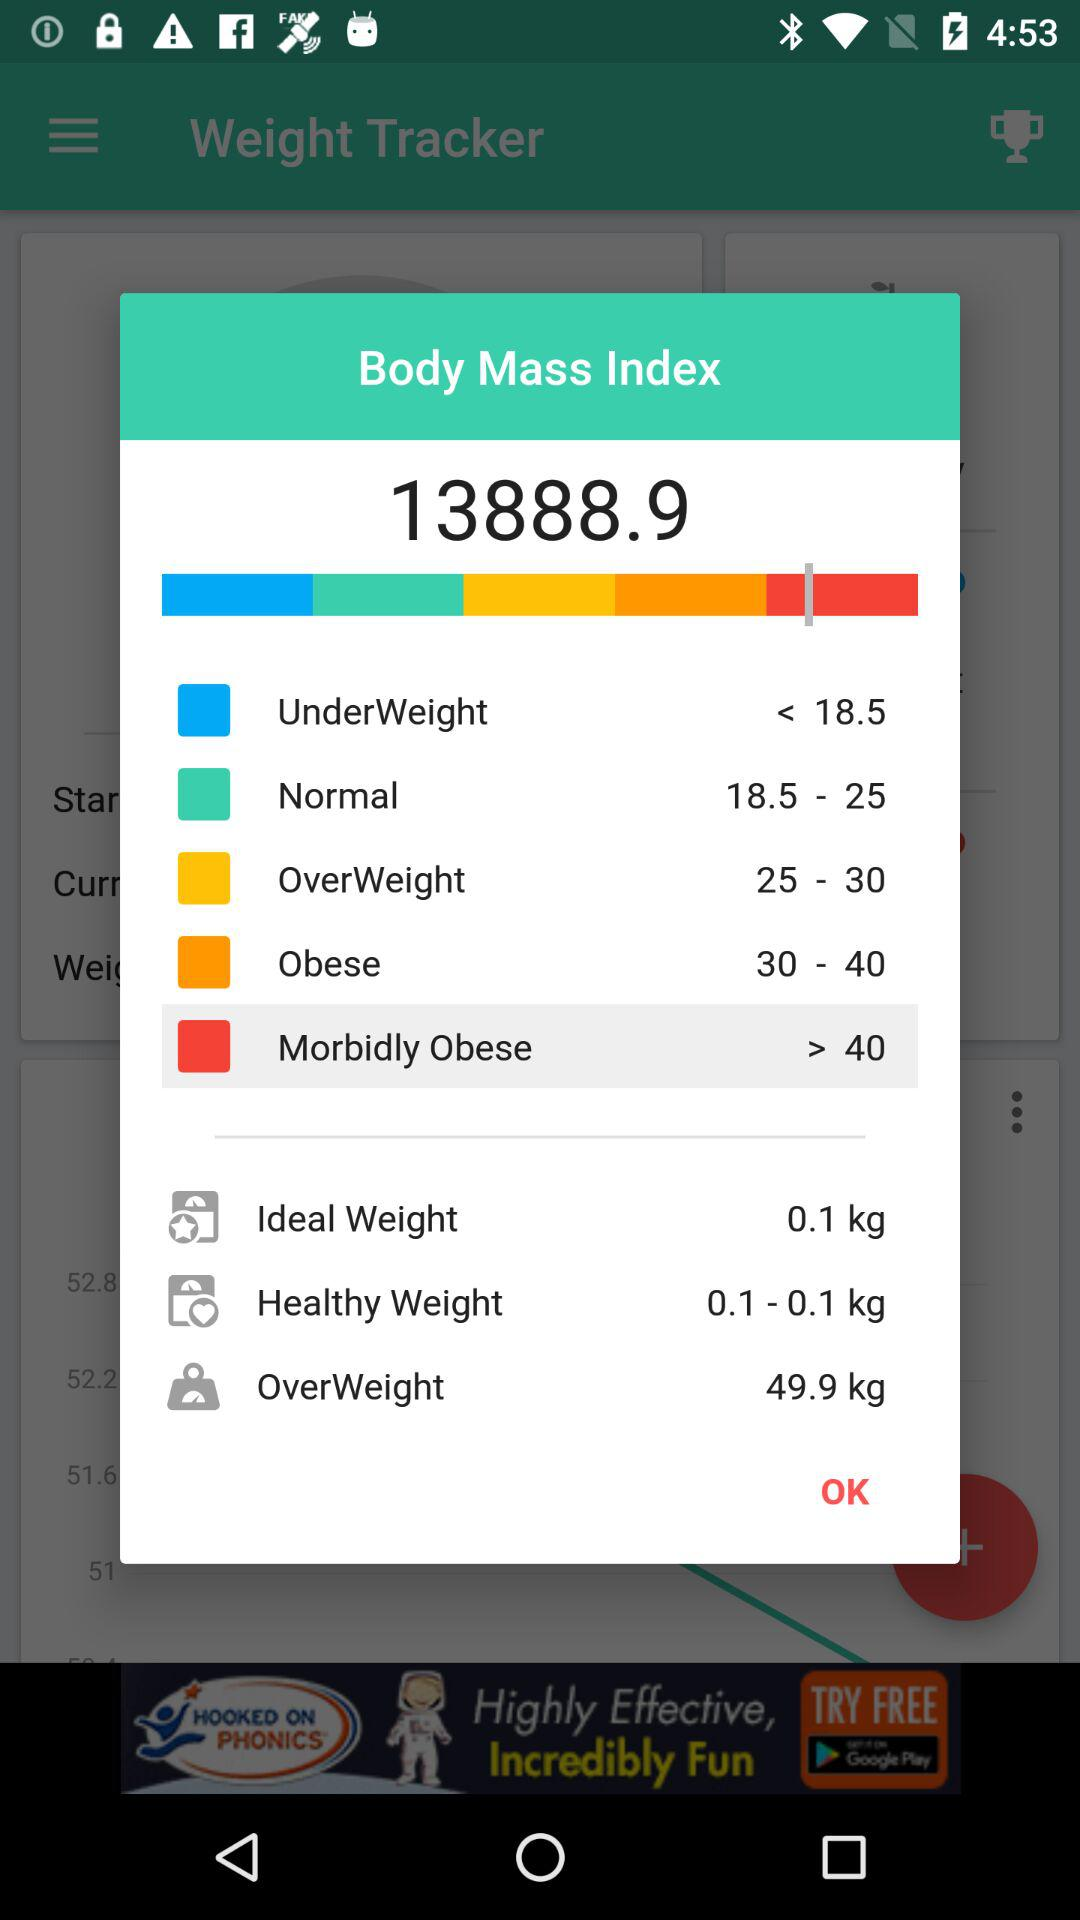What is the weight considered underweight? The weight considered to be underweight is 18.5 kg. 